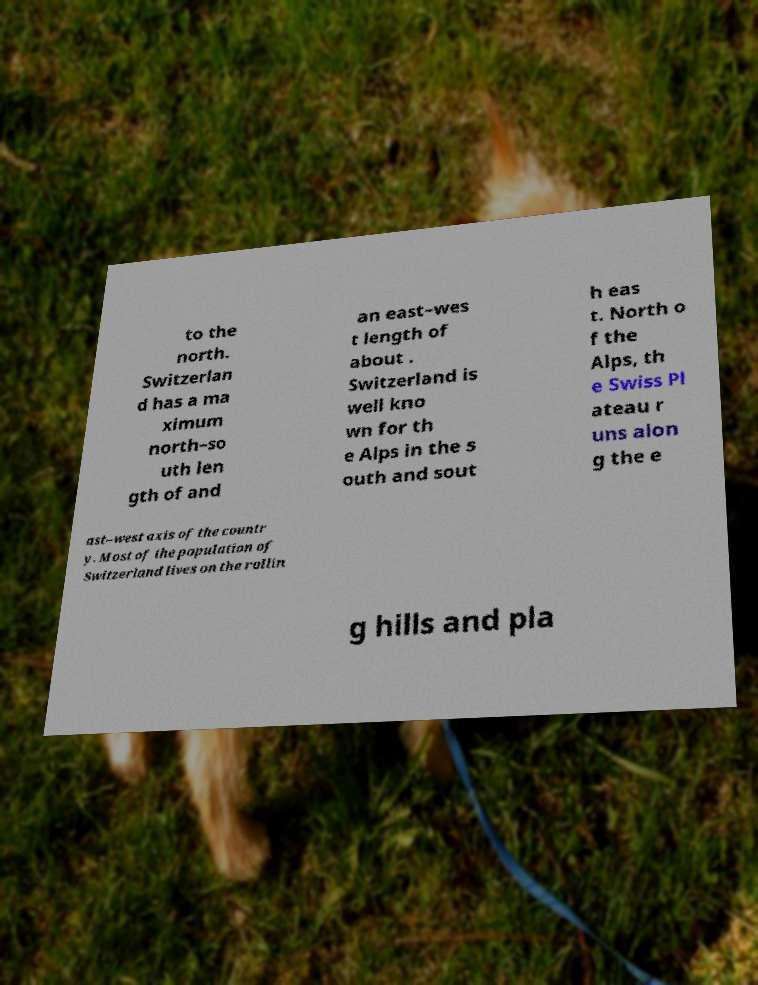Could you extract and type out the text from this image? to the north. Switzerlan d has a ma ximum north–so uth len gth of and an east–wes t length of about . Switzerland is well kno wn for th e Alps in the s outh and sout h eas t. North o f the Alps, th e Swiss Pl ateau r uns alon g the e ast–west axis of the countr y. Most of the population of Switzerland lives on the rollin g hills and pla 